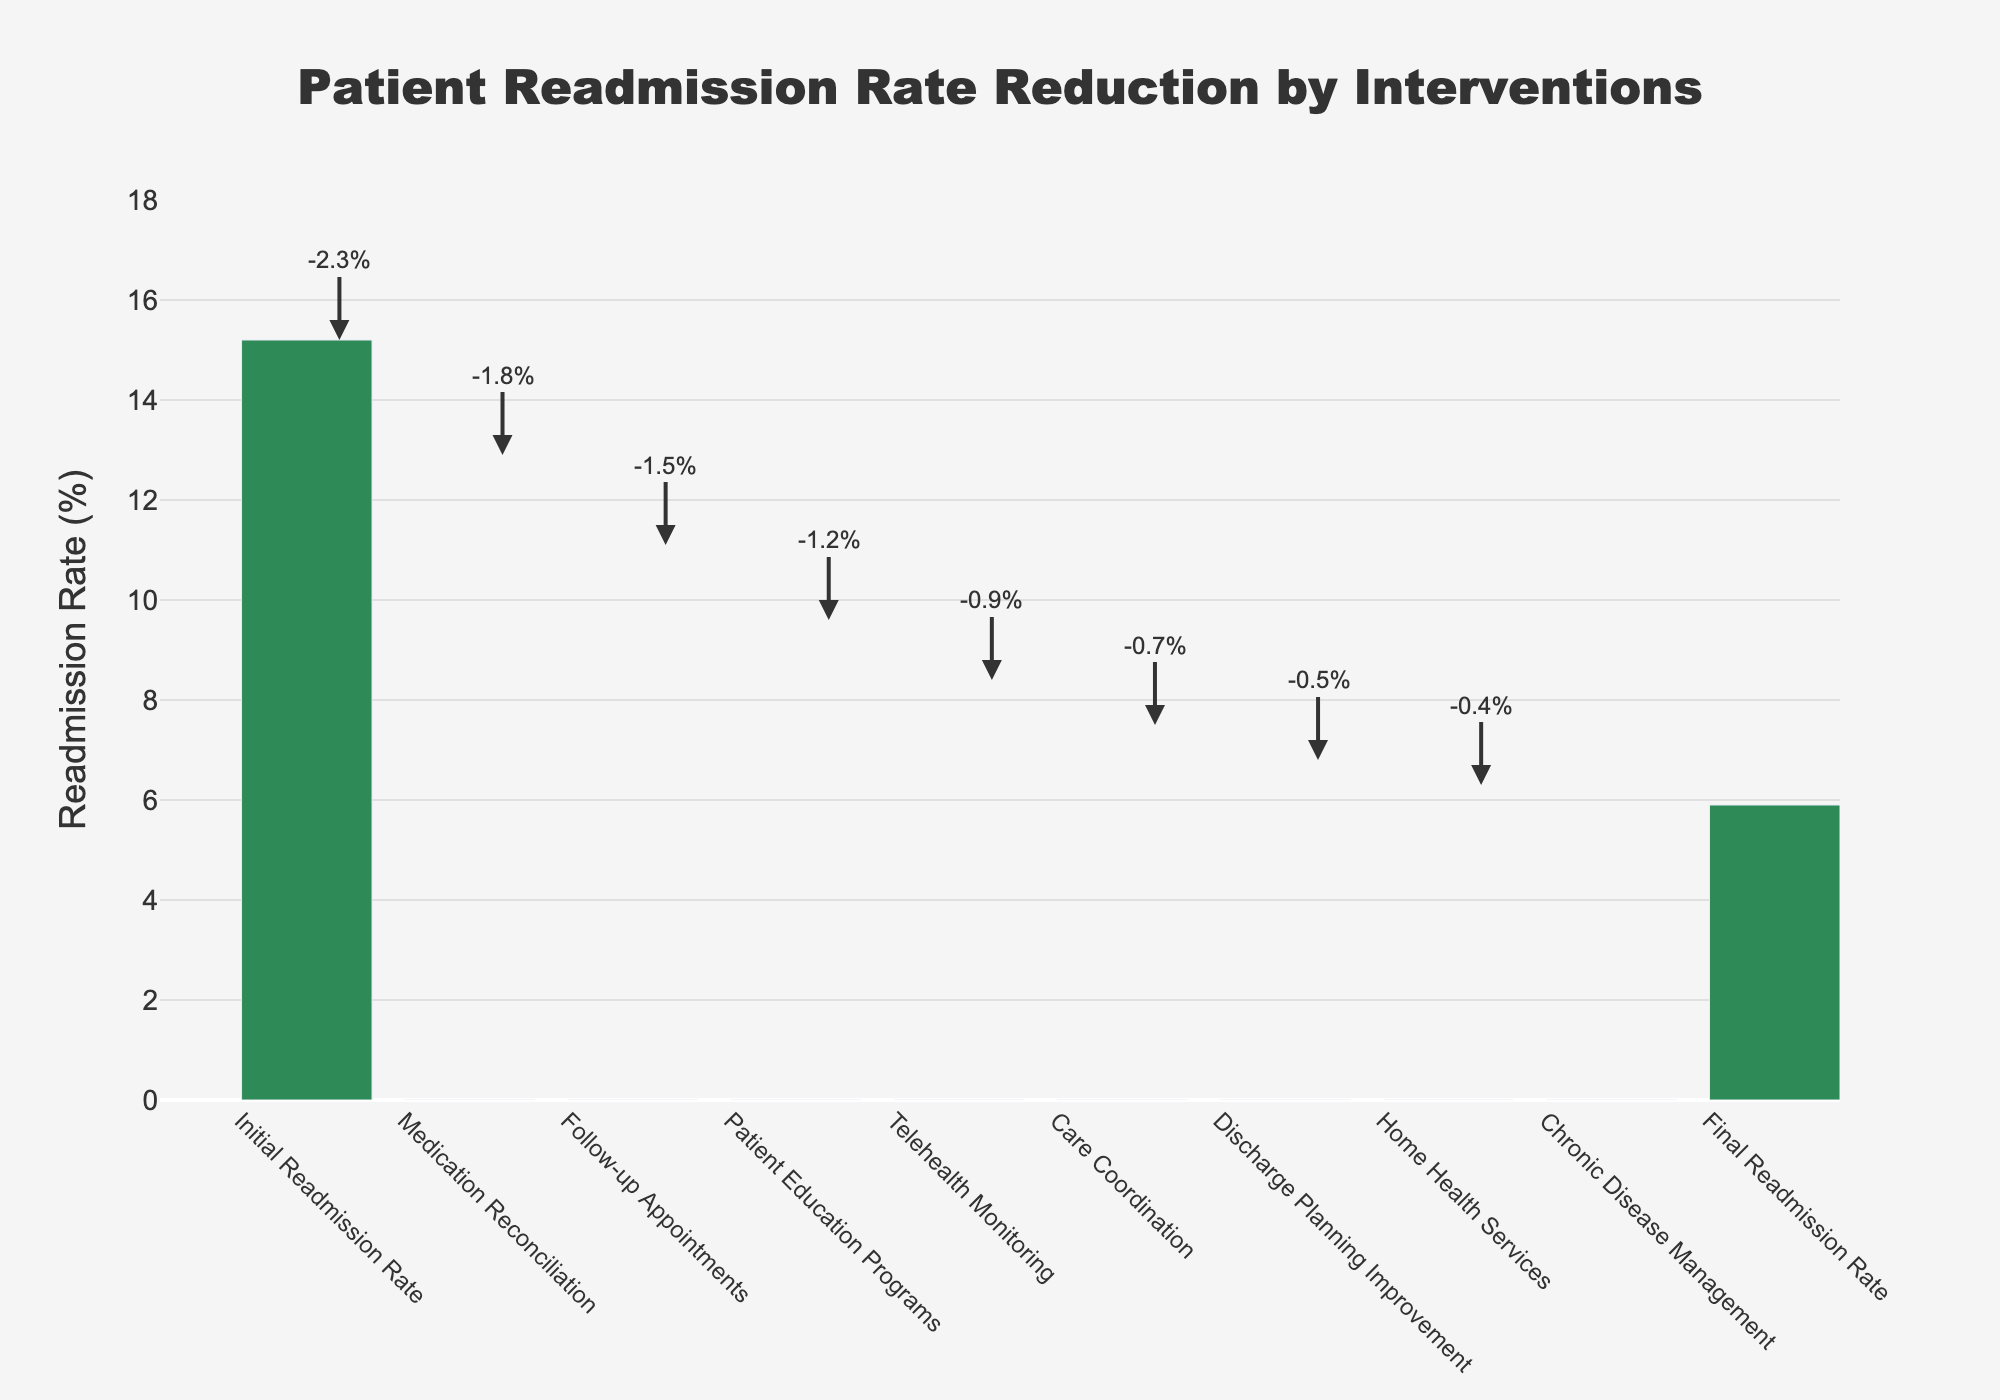What is the title of the chart? The title of the chart is displayed prominently at the top; it reads "Patient Readmission Rate Reduction by Interventions."
Answer: Patient Readmission Rate Reduction by Interventions What is the initial readmission rate before any interventions? The initial readmission rate is shown as the first bar in the chart, which has a value of 15.2%.
Answer: 15.2% Which intervention had the largest impact on reducing the readmission rate? By comparing the lengths of the bars, the Medication Reconciliation intervention had the largest negative value (-2.3%), indicating the most significant reduction in readmission rates.
Answer: Medication Reconciliation What is the final readmission rate after all interventions? The final readmission rate is indicated by the last bar in the chart, which shows a value of 5.9%.
Answer: 5.9% How much did the Follow-up Appointments intervention reduce the readmission rate? The impact of the Follow-up Appointments intervention is represented by the bar corresponding to it, showing a reduction of 1.8%.
Answer: 1.8% What is the cumulative reduction in readmission rate from Medication Reconciliation and Follow-up Appointments? The reduction from Medication Reconciliation is 2.3%, and from Follow-up Appointments is 1.8%. Adding these gives 2.3% + 1.8% = 4.1%.
Answer: 4.1% How does the impact of Care Coordination compare to that of Patient Education Programs? Care Coordination reduces the readmission rate by 0.9%, while Patient Education Programs reduce it by 1.5%. Since 0.9% is less than 1.5%, Care Coordination has a smaller impact.
Answer: Care Coordination has a smaller impact Which intervention had the smallest reduction in the readmission rate? By observing the length of the bars, the Chronic Disease Management intervention has the smallest reduction of 0.4%.
Answer: Chronic Disease Management What is the total reduction in readmission rate achieved by all interventions? Adding up all the reductions: -2.3% (Medication Reconciliation) + -1.8% (Follow-up Appointments) + -1.5% (Patient Education Programs) + -1.2% (Telehealth Monitoring) + -0.9% (Care Coordination) + -0.7% (Discharge Planning Improvement) + -0.5% (Home Health Services) + -0.4% (Chronic Disease Management) = -9.3%.
Answer: 9.3% What is the average reduction in readmission rate per intervention? The total reduction is 9.3% over 8 interventions. Dividing total reduction by number of interventions gives 9.3% / 8 = 1.1625%.
Answer: 1.16% 